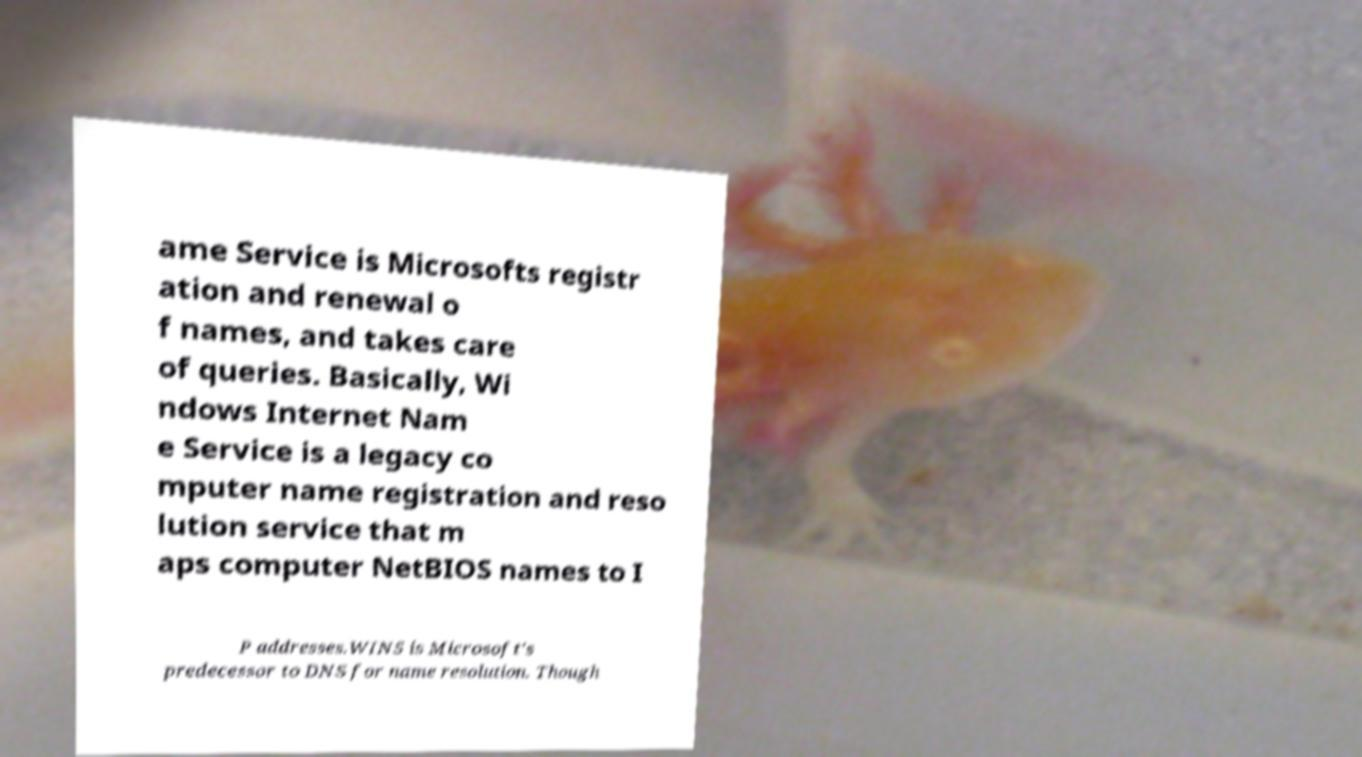Could you extract and type out the text from this image? ame Service is Microsofts registr ation and renewal o f names, and takes care of queries. Basically, Wi ndows Internet Nam e Service is a legacy co mputer name registration and reso lution service that m aps computer NetBIOS names to I P addresses.WINS is Microsoft's predecessor to DNS for name resolution. Though 